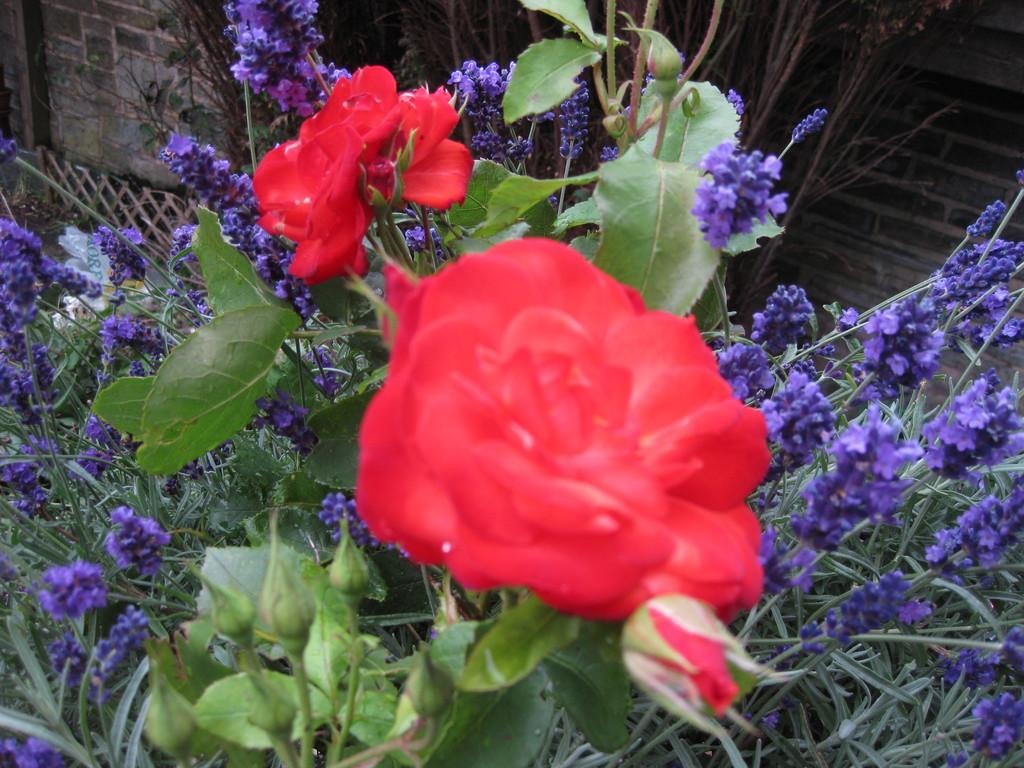What type of living organisms can be seen in the image? There are flowers and plants visible in the image. What is located behind the plants in the image? There is a wall visible behind the plants. What invention is being demonstrated by the flowers in the image? There is no invention being demonstrated by the flowers in the image; they are simply plants. 